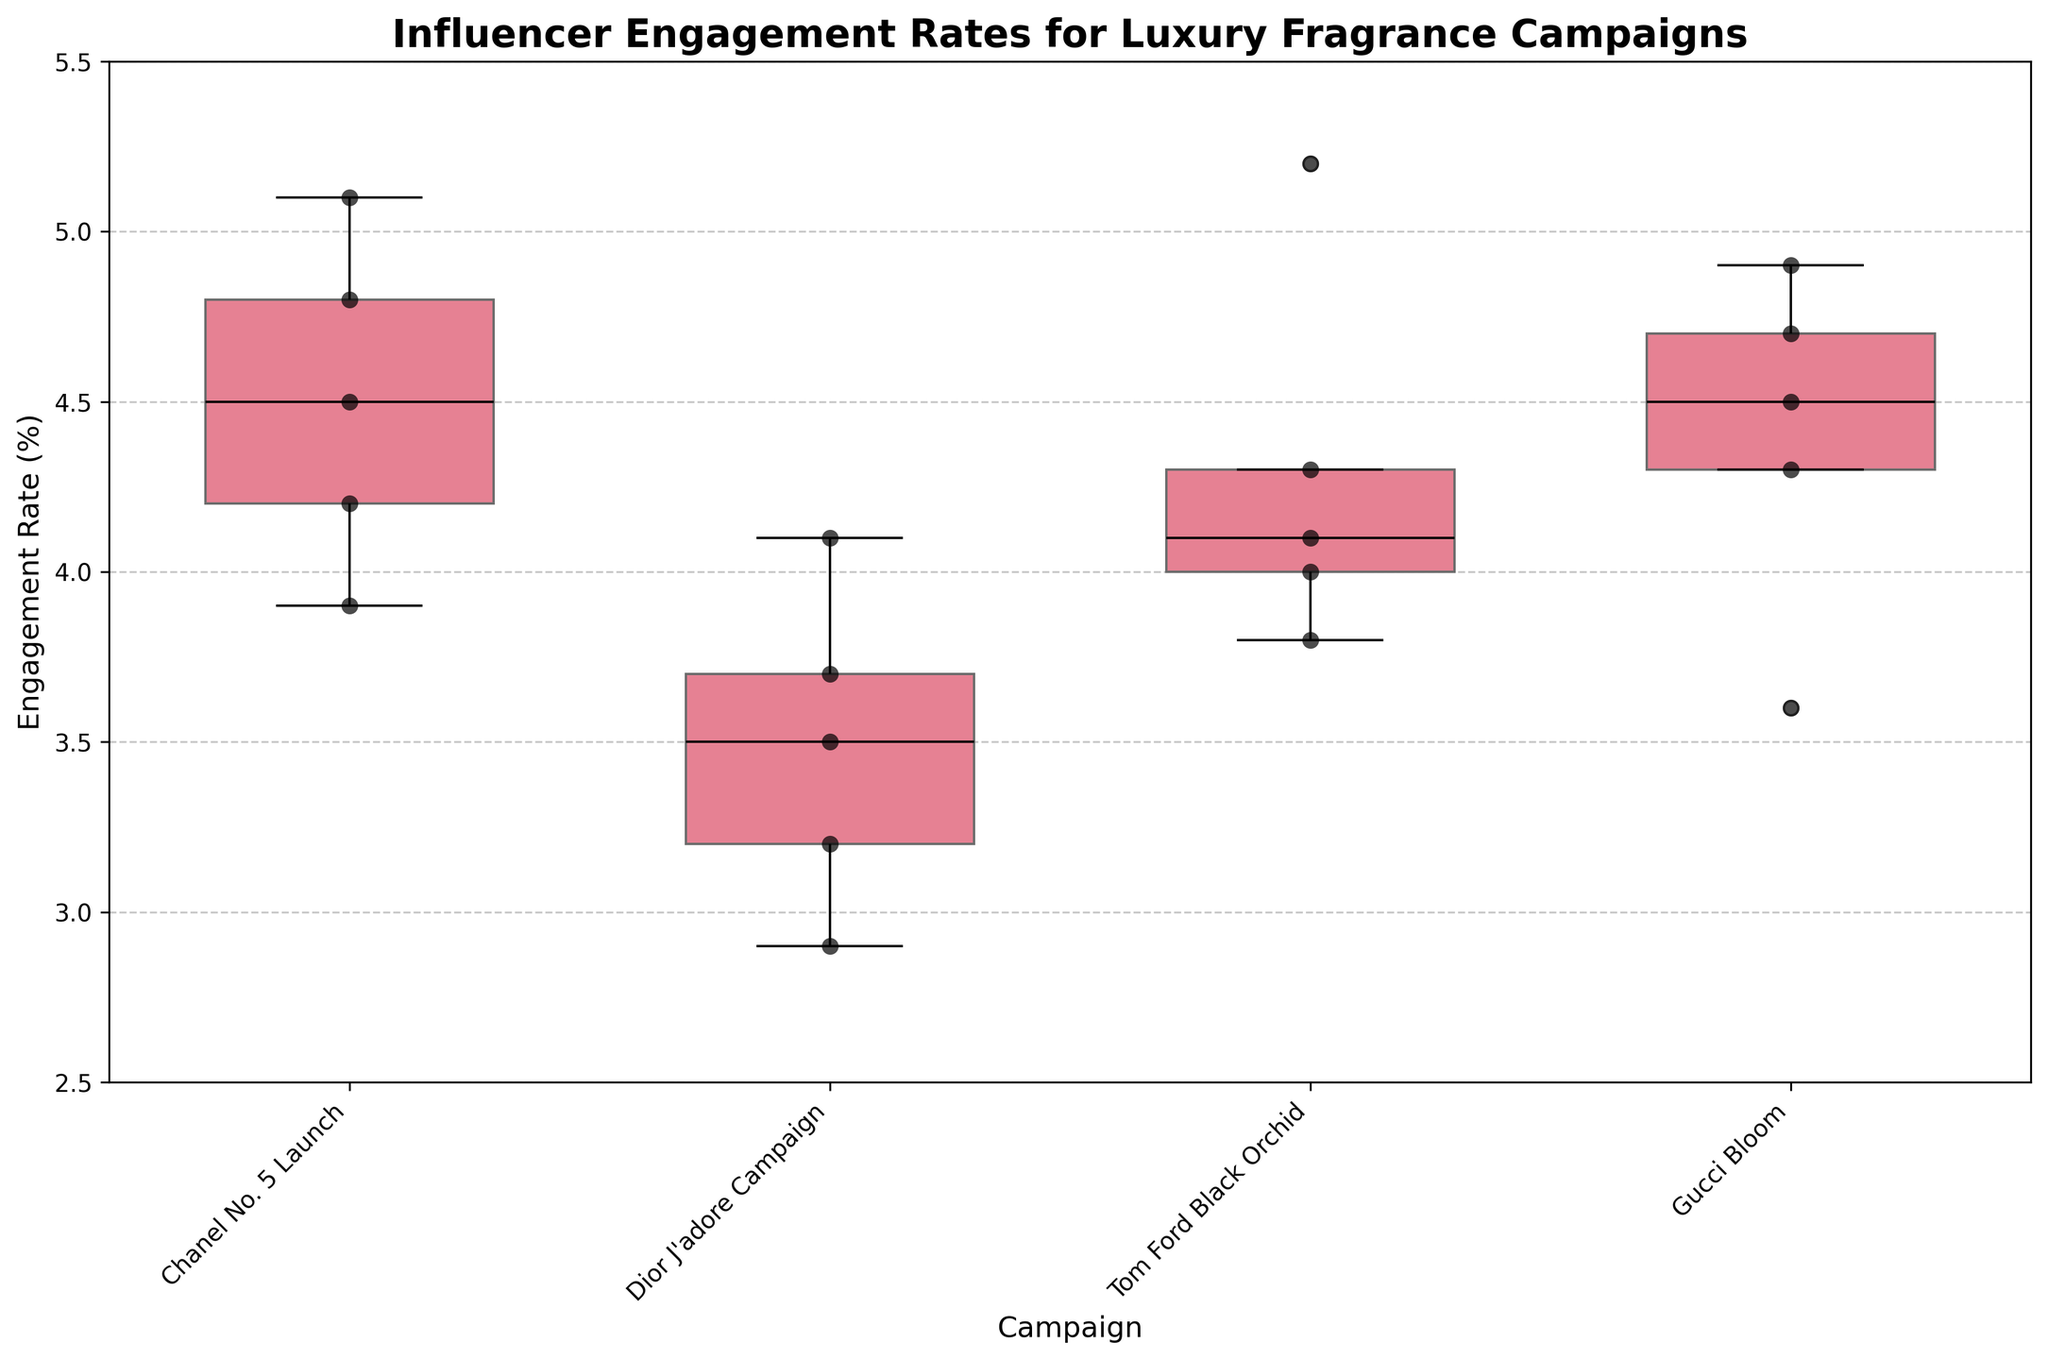What is the title of the plot? The title of the plot is shown at the top of the figure. It states the central theme or focus of the data being presented.
Answer: Influencer Engagement Rates for Luxury Fragrance Campaigns Which campaign has the highest median engagement rate? The median engagement rate of a campaign can be found at the center line inside the box of the box plot.
Answer: Chanel No. 5 Launch How many influencers were involved in the Dior J'adore Campaign? Counting the number of individual data points (black dots) in the Dior J'adore Campaign box plot gives the number of influencers.
Answer: 5 What is the range of engagement rates for the Tom Ford Black Orchid campaign? The range can be calculated by finding the difference between the maximum and minimum values of the engagement rates for the Tom Ford Black Orchid campaign. The maximum and minimum values are represented by the top and bottom of the whiskers.
Answer: 2.3 (5.2 - 2.9) Which influencer had the highest engagement rate in the Tom Ford Black Orchid campaign, and what was this rate? By looking at the scatter points, the highest point in the Tom Ford Black Orchid campaign represents the highest engagement rate.
Answer: Mariano Di Vaio, 5.2% Compare the interquartile ranges (IQR) of the Gucci Bloom campaign with the Dior J'adore Campaign. Which campaign has a larger IQR? The IQR is represented by the height of the box. By visually comparing the heights of the boxes for the Gucci Bloom and Dior J'adore campaigns, we can determine which has a larger IQR.
Answer: Gucci Bloom Is there any noticeable outlier in any of the campaigns? Outliers are typically represented by individual points that fall outside the whiskers in a box plot.
Answer: No How does the average engagement rate of the Chanel No. 5 Launch compare to the overall average engagement rate of all campaigns combined? Calculate the average engagement rate for Chanel No. 5 and then compare it to the mean of all engagement rates from every campaign. The Chanel No. 5 average is calculated, and the overall average includes summing all engagement rates and dividing by the total number of data points.
Answer: Chanel No. 5 is higher Which campaign shows the most variability in influencer engagement rates? Variability can be inferred from the length of the whiskers and the size of the IQR in each box plot. The campaign with the largest overall spread from the bottom whisker to the top whisker has the most variability.
Answer: Dior J'adore Campaign 